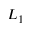<formula> <loc_0><loc_0><loc_500><loc_500>L _ { 1 }</formula> 